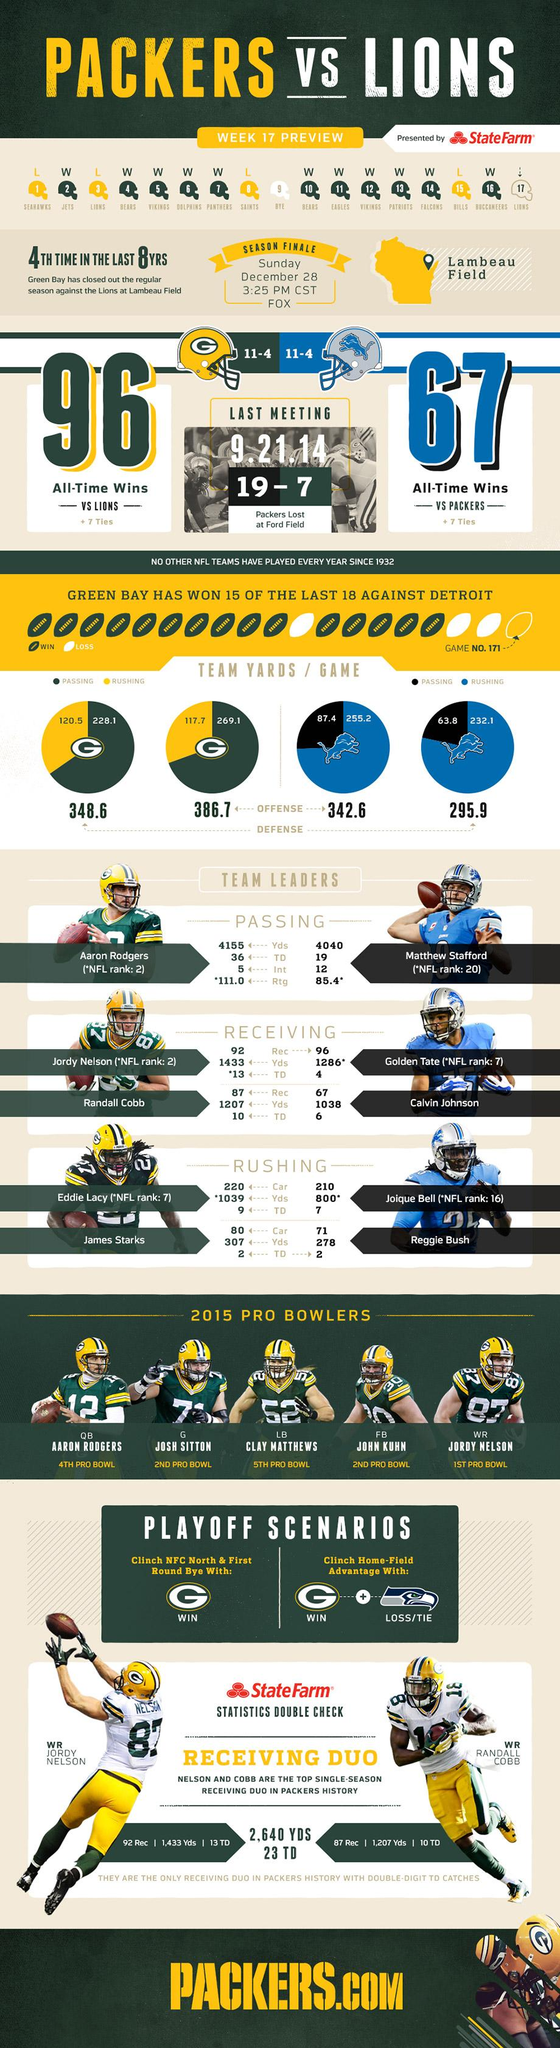Give some essential details in this illustration. The player wearing the jersey number 87 is Jordy Nelson. The offensive passing score of the Green Bay Packers is 269.1. The Green Bay Packers have lost four games prior to the start of week 17. The sixteenth ranked player on the National Football League is Joique Bell, formerly of the Detroit Lions. The defensive rushing score of the Green Bay Packers is 120.5. 